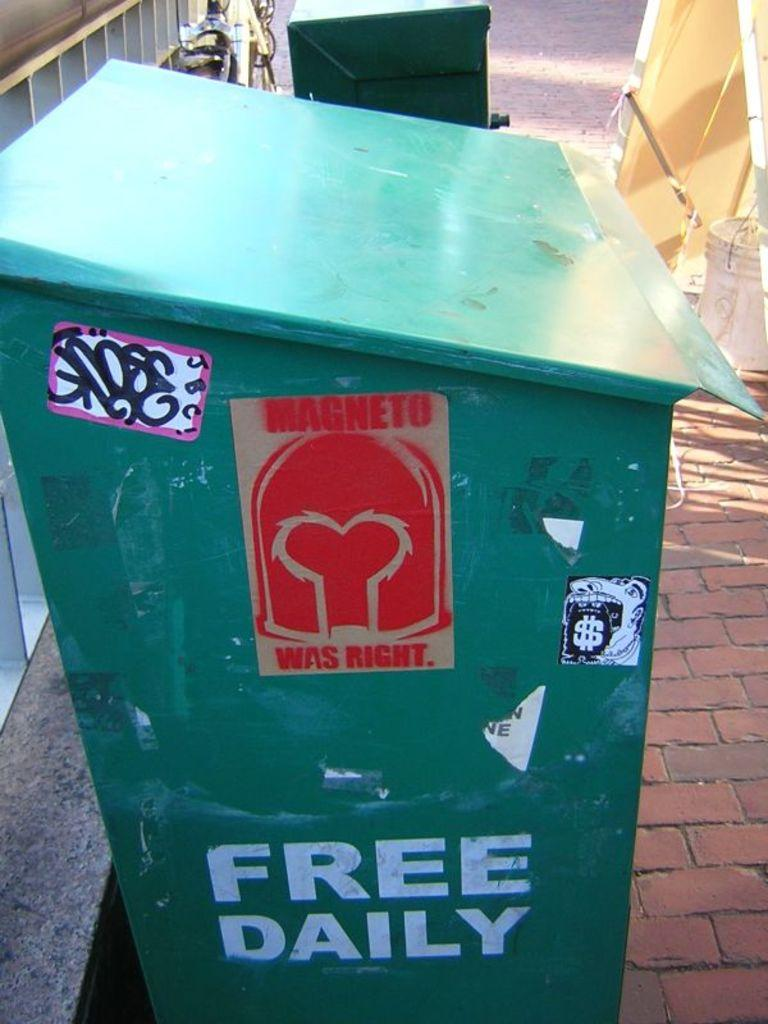Provide a one-sentence caption for the provided image. Free daily sign and magneto was right sign on a green can. 